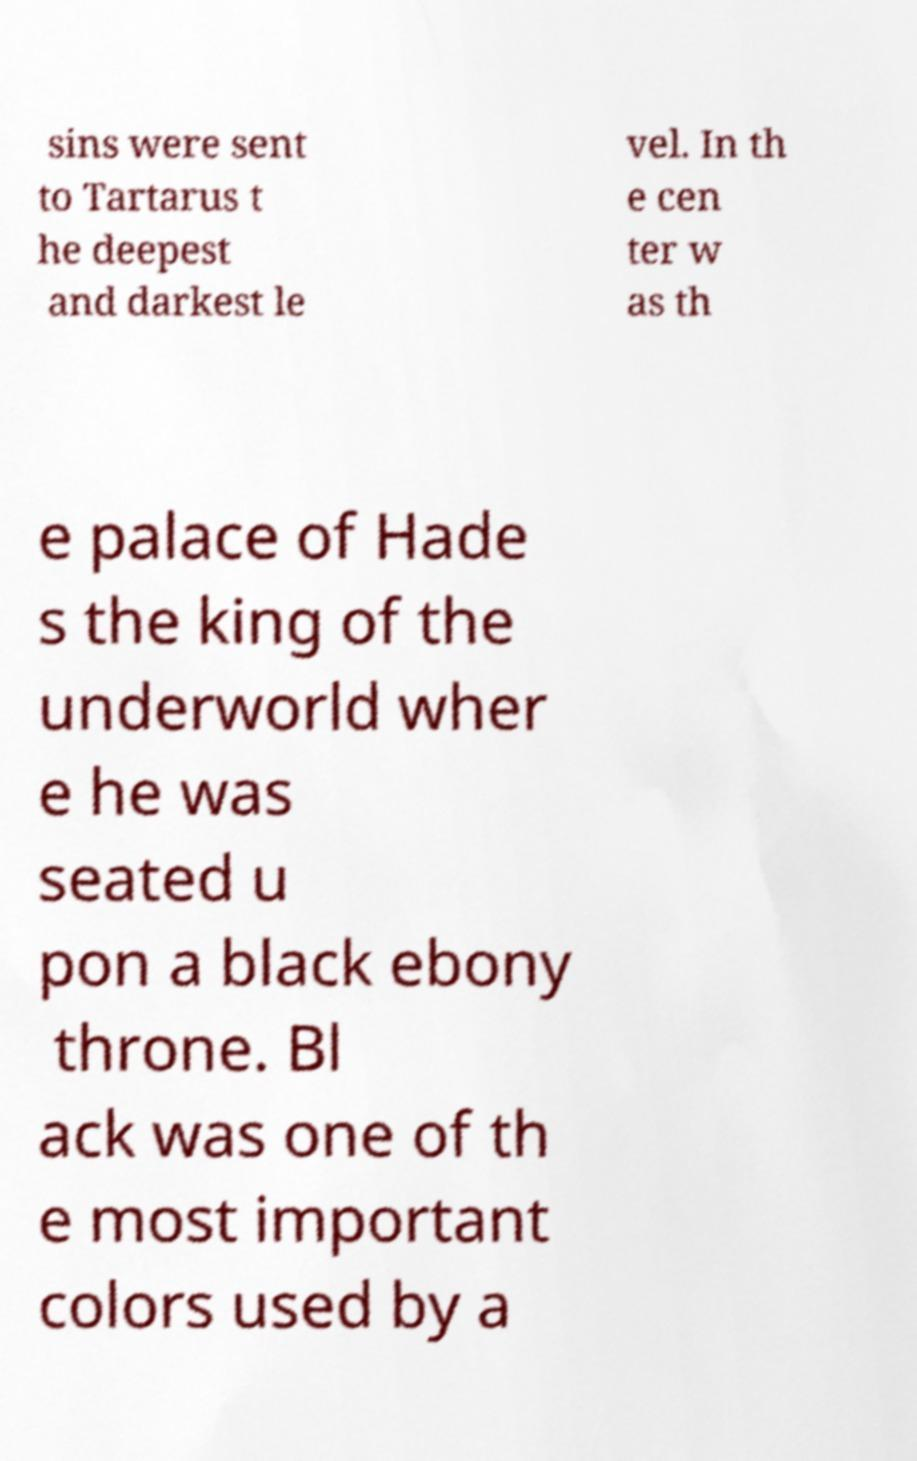For documentation purposes, I need the text within this image transcribed. Could you provide that? sins were sent to Tartarus t he deepest and darkest le vel. In th e cen ter w as th e palace of Hade s the king of the underworld wher e he was seated u pon a black ebony throne. Bl ack was one of th e most important colors used by a 